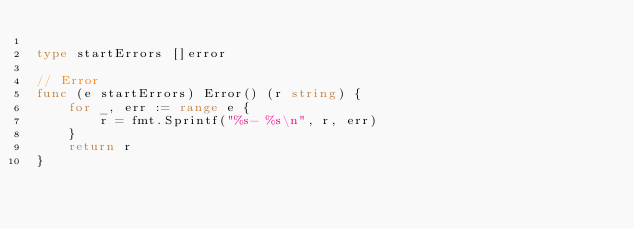Convert code to text. <code><loc_0><loc_0><loc_500><loc_500><_Go_>
type startErrors []error

// Error
func (e startErrors) Error() (r string) {
	for _, err := range e {
		r = fmt.Sprintf("%s- %s\n", r, err)
	}
	return r
}
</code> 